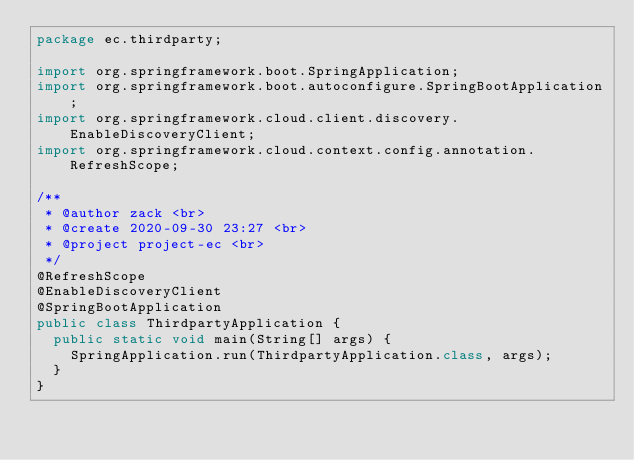Convert code to text. <code><loc_0><loc_0><loc_500><loc_500><_Java_>package ec.thirdparty;

import org.springframework.boot.SpringApplication;
import org.springframework.boot.autoconfigure.SpringBootApplication;
import org.springframework.cloud.client.discovery.EnableDiscoveryClient;
import org.springframework.cloud.context.config.annotation.RefreshScope;

/**
 * @author zack <br>
 * @create 2020-09-30 23:27 <br>
 * @project project-ec <br>
 */
@RefreshScope
@EnableDiscoveryClient
@SpringBootApplication
public class ThirdpartyApplication {
  public static void main(String[] args) {
    SpringApplication.run(ThirdpartyApplication.class, args);
  }
}
</code> 